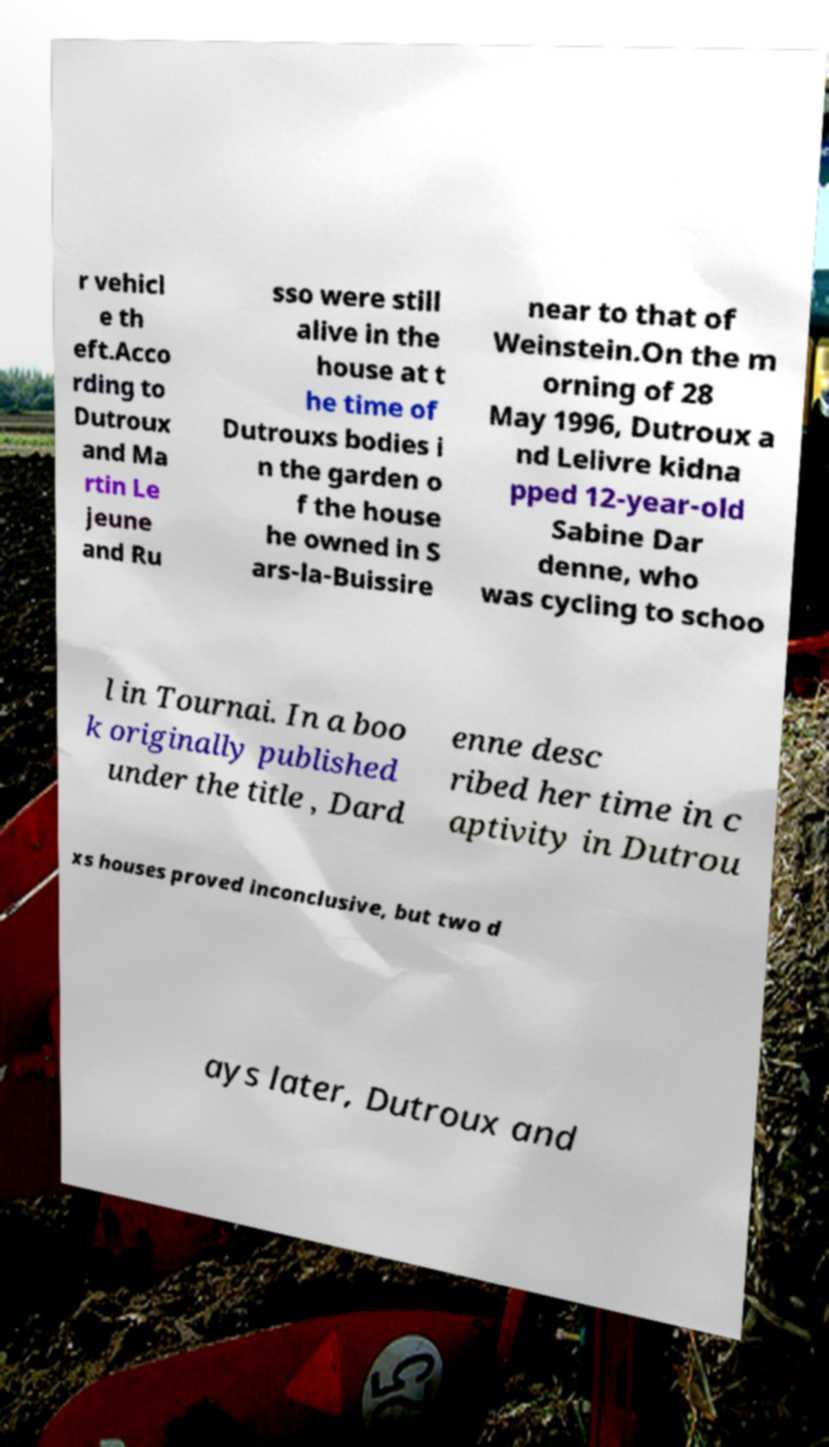For documentation purposes, I need the text within this image transcribed. Could you provide that? r vehicl e th eft.Acco rding to Dutroux and Ma rtin Le jeune and Ru sso were still alive in the house at t he time of Dutrouxs bodies i n the garden o f the house he owned in S ars-la-Buissire near to that of Weinstein.On the m orning of 28 May 1996, Dutroux a nd Lelivre kidna pped 12-year-old Sabine Dar denne, who was cycling to schoo l in Tournai. In a boo k originally published under the title , Dard enne desc ribed her time in c aptivity in Dutrou xs houses proved inconclusive, but two d ays later, Dutroux and 